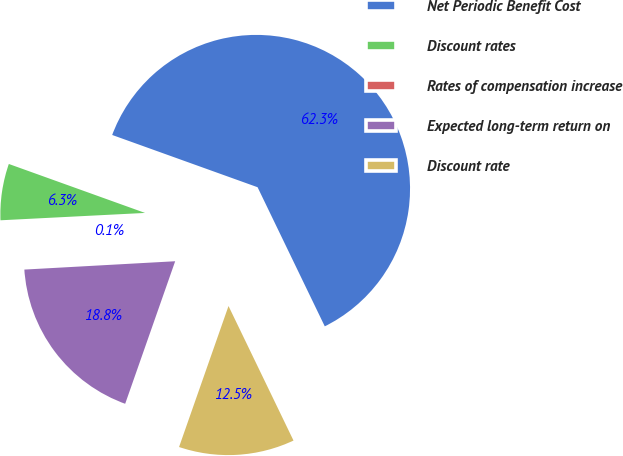Convert chart. <chart><loc_0><loc_0><loc_500><loc_500><pie_chart><fcel>Net Periodic Benefit Cost<fcel>Discount rates<fcel>Rates of compensation increase<fcel>Expected long-term return on<fcel>Discount rate<nl><fcel>62.34%<fcel>6.3%<fcel>0.07%<fcel>18.75%<fcel>12.53%<nl></chart> 